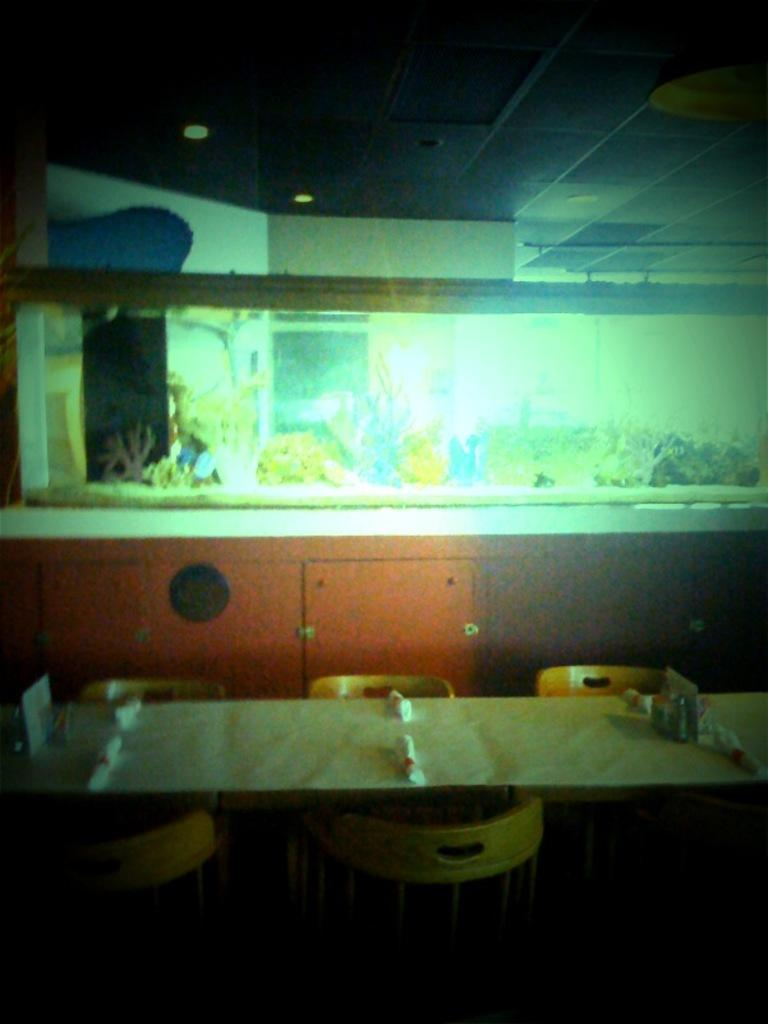What type of furniture is present in the image? There is a table and chairs in the image. What can be seen on the wall in the image? There is a big frame on the wall in the image. What is the price of the whip hanging on the wall in the image? There is no whip present in the image, so it is not possible to determine its price. 